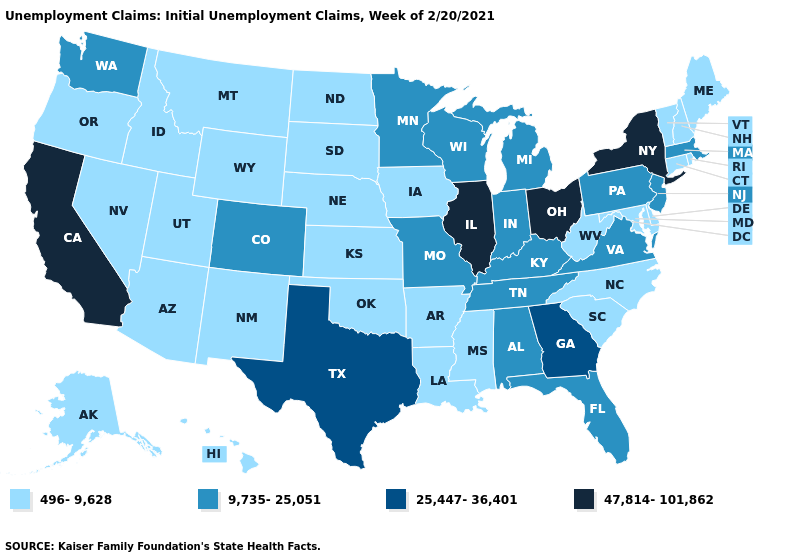Among the states that border Florida , does Alabama have the lowest value?
Keep it brief. Yes. Does the map have missing data?
Short answer required. No. Among the states that border Rhode Island , does Connecticut have the highest value?
Answer briefly. No. Among the states that border California , which have the highest value?
Answer briefly. Arizona, Nevada, Oregon. How many symbols are there in the legend?
Concise answer only. 4. Name the states that have a value in the range 47,814-101,862?
Answer briefly. California, Illinois, New York, Ohio. What is the lowest value in states that border Virginia?
Write a very short answer. 496-9,628. Does the map have missing data?
Short answer required. No. Name the states that have a value in the range 25,447-36,401?
Keep it brief. Georgia, Texas. Which states have the highest value in the USA?
Give a very brief answer. California, Illinois, New York, Ohio. What is the lowest value in states that border Pennsylvania?
Answer briefly. 496-9,628. Among the states that border New Hampshire , which have the lowest value?
Give a very brief answer. Maine, Vermont. Does California have the highest value in the West?
Be succinct. Yes. Name the states that have a value in the range 9,735-25,051?
Concise answer only. Alabama, Colorado, Florida, Indiana, Kentucky, Massachusetts, Michigan, Minnesota, Missouri, New Jersey, Pennsylvania, Tennessee, Virginia, Washington, Wisconsin. What is the highest value in the USA?
Short answer required. 47,814-101,862. 